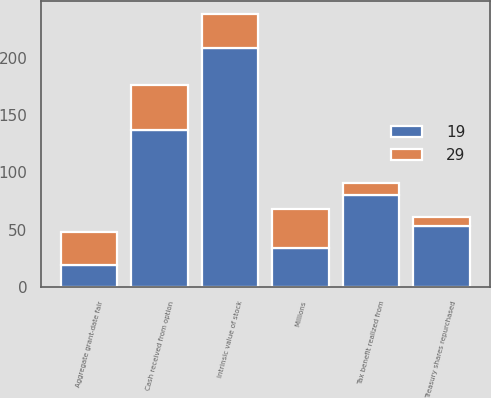Convert chart. <chart><loc_0><loc_0><loc_500><loc_500><stacked_bar_chart><ecel><fcel>Millions<fcel>Intrinsic value of stock<fcel>Cash received from option<fcel>Treasury shares repurchased<fcel>Tax benefit realized from<fcel>Aggregate grant-date fair<nl><fcel>19<fcel>34<fcel>209<fcel>137<fcel>53<fcel>80<fcel>19<nl><fcel>29<fcel>34<fcel>29<fcel>39<fcel>8<fcel>11<fcel>29<nl></chart> 